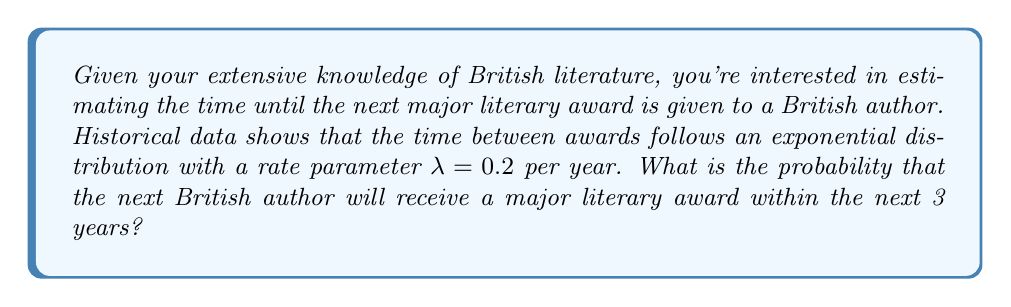Can you solve this math problem? To solve this problem, we'll use survival analysis techniques, specifically the properties of the exponential distribution.

Step 1: Identify the given information
- The time between awards follows an exponential distribution
- The rate parameter $\lambda = 0.2$ per year
- We want to find the probability of an award within 3 years

Step 2: Recall the survival function for the exponential distribution
The survival function $S(t)$ gives the probability that the event occurs after time $t$:
$$S(t) = e^{-\lambda t}$$

Step 3: Calculate the probability of no award within 3 years
$$S(3) = e^{-0.2 \cdot 3} = e^{-0.6}$$

Step 4: Calculate the probability of an award within 3 years
The probability we're looking for is the complement of the survival function:
$$P(\text{award within 3 years}) = 1 - S(3) = 1 - e^{-0.6}$$

Step 5: Compute the final result
$$1 - e^{-0.6} \approx 0.4512$$

Therefore, the probability that a British author will receive a major literary award within the next 3 years is approximately 0.4512 or 45.12%.
Answer: $1 - e^{-0.6} \approx 0.4512$ 